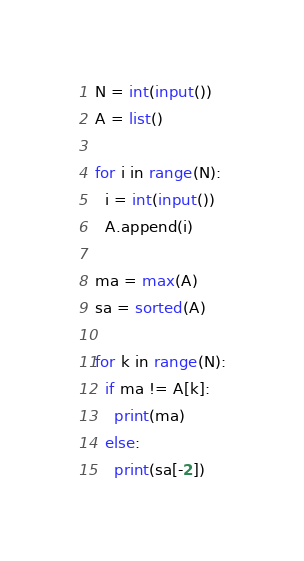Convert code to text. <code><loc_0><loc_0><loc_500><loc_500><_Python_>N = int(input())
A = list()

for i in range(N):
  i = int(input())
  A.append(i)
  
ma = max(A)
sa = sorted(A)

for k in range(N):
  if ma != A[k]:
    print(ma)
  else:
    print(sa[-2])</code> 